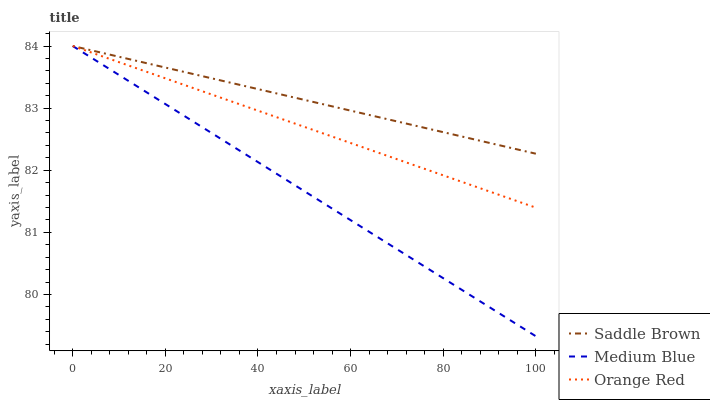Does Orange Red have the minimum area under the curve?
Answer yes or no. No. Does Orange Red have the maximum area under the curve?
Answer yes or no. No. Is Orange Red the smoothest?
Answer yes or no. No. Is Saddle Brown the roughest?
Answer yes or no. No. Does Orange Red have the lowest value?
Answer yes or no. No. 